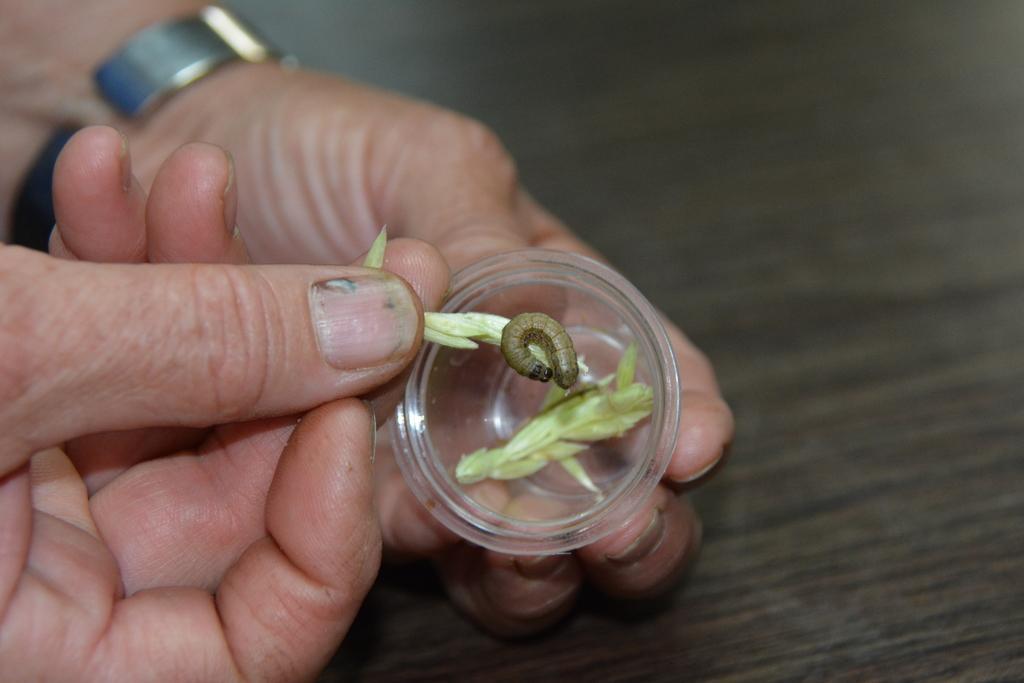Can you describe this image briefly? In this picture we can see a person's hands, this person is holding a cup, we can see petals of a flower and a caterpillar, there is a blurry background. 